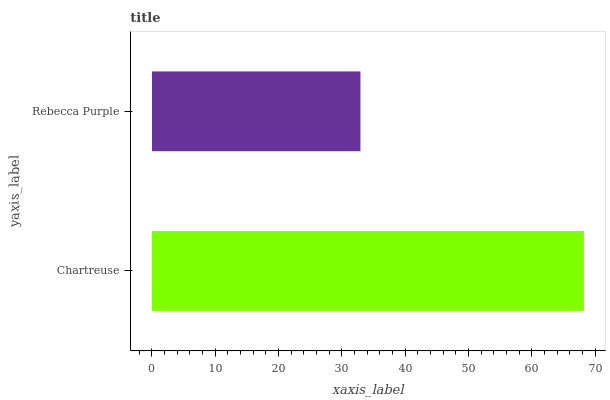Is Rebecca Purple the minimum?
Answer yes or no. Yes. Is Chartreuse the maximum?
Answer yes or no. Yes. Is Rebecca Purple the maximum?
Answer yes or no. No. Is Chartreuse greater than Rebecca Purple?
Answer yes or no. Yes. Is Rebecca Purple less than Chartreuse?
Answer yes or no. Yes. Is Rebecca Purple greater than Chartreuse?
Answer yes or no. No. Is Chartreuse less than Rebecca Purple?
Answer yes or no. No. Is Chartreuse the high median?
Answer yes or no. Yes. Is Rebecca Purple the low median?
Answer yes or no. Yes. Is Rebecca Purple the high median?
Answer yes or no. No. Is Chartreuse the low median?
Answer yes or no. No. 